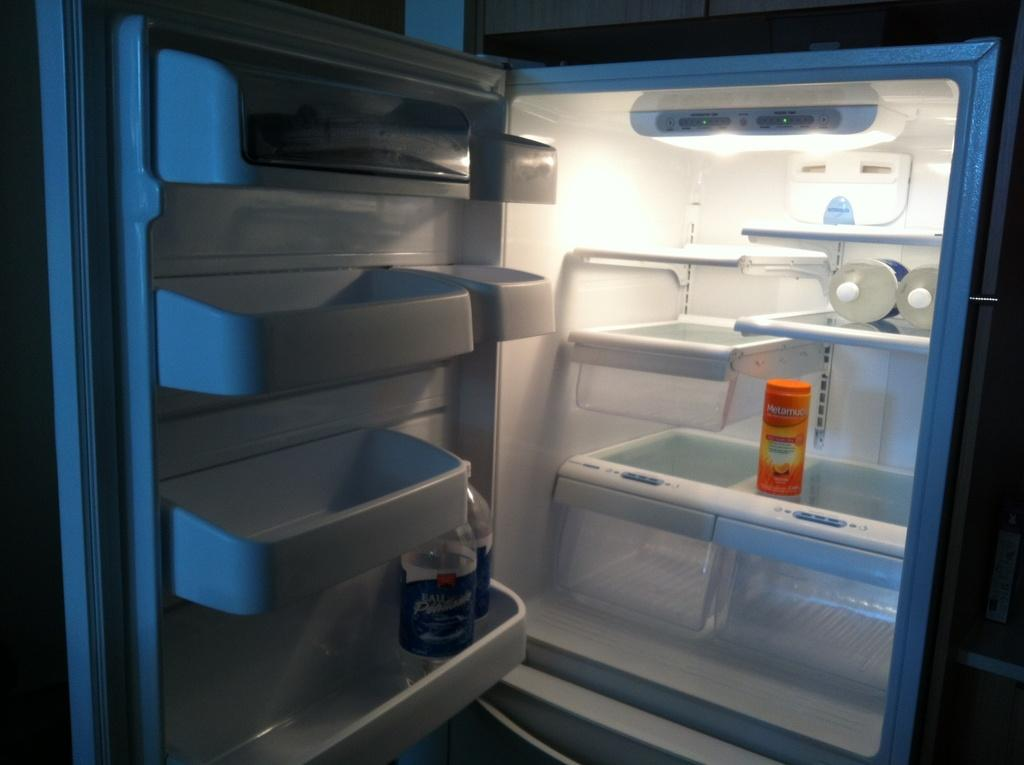<image>
Provide a brief description of the given image. An open refrigerator with a bottle of Metamucil in it. 